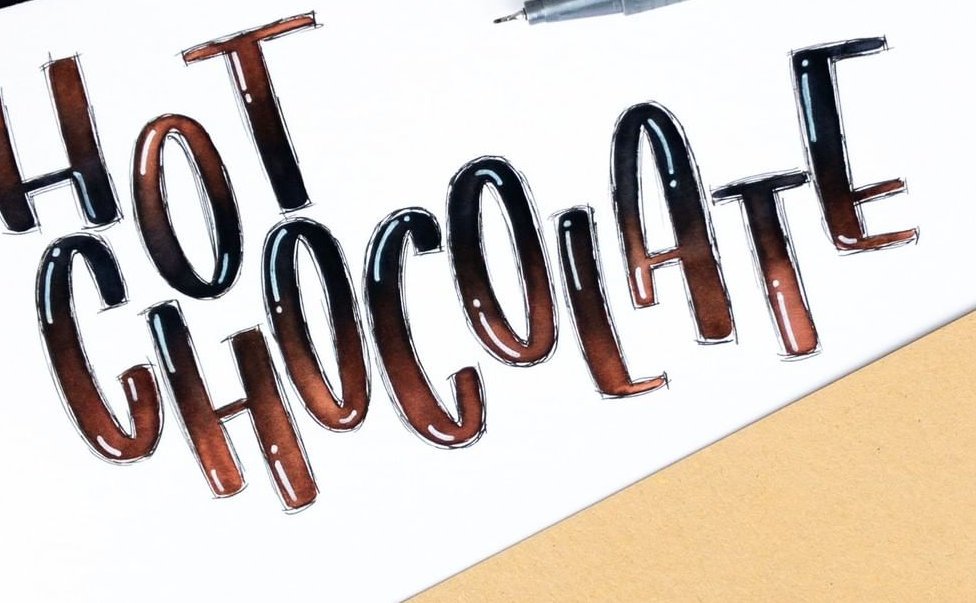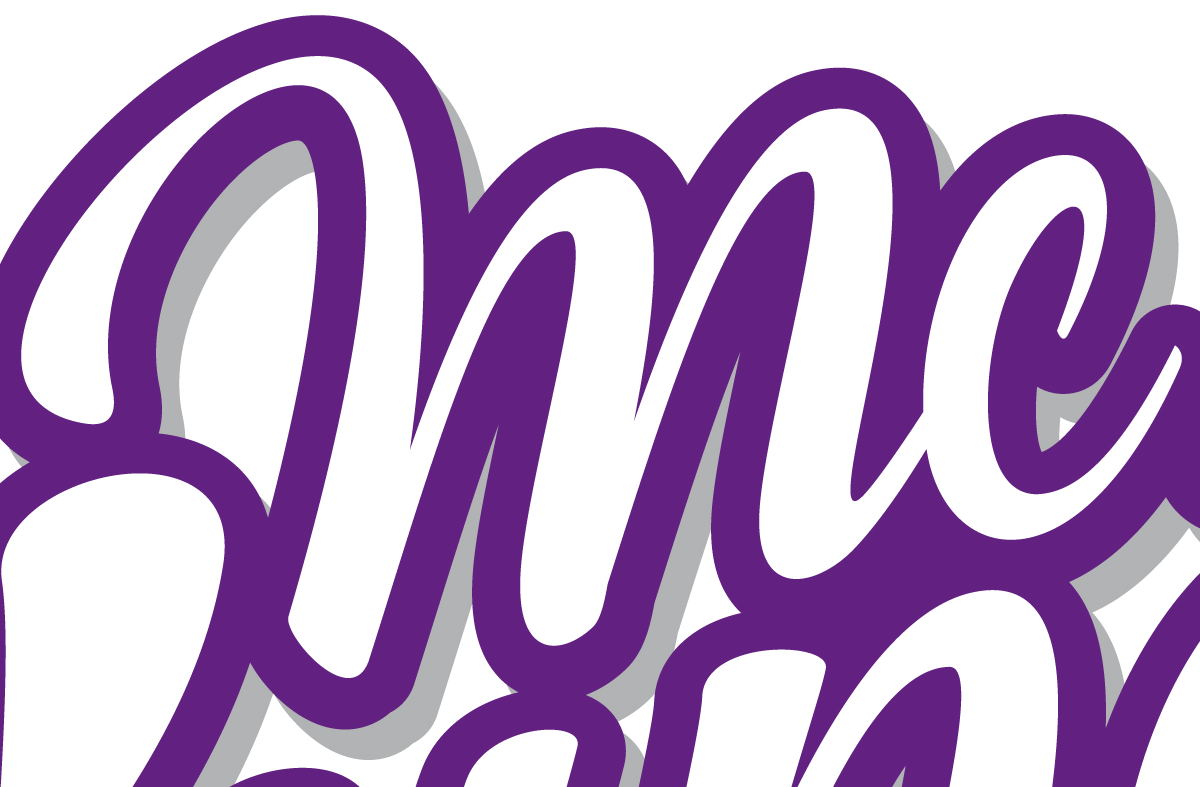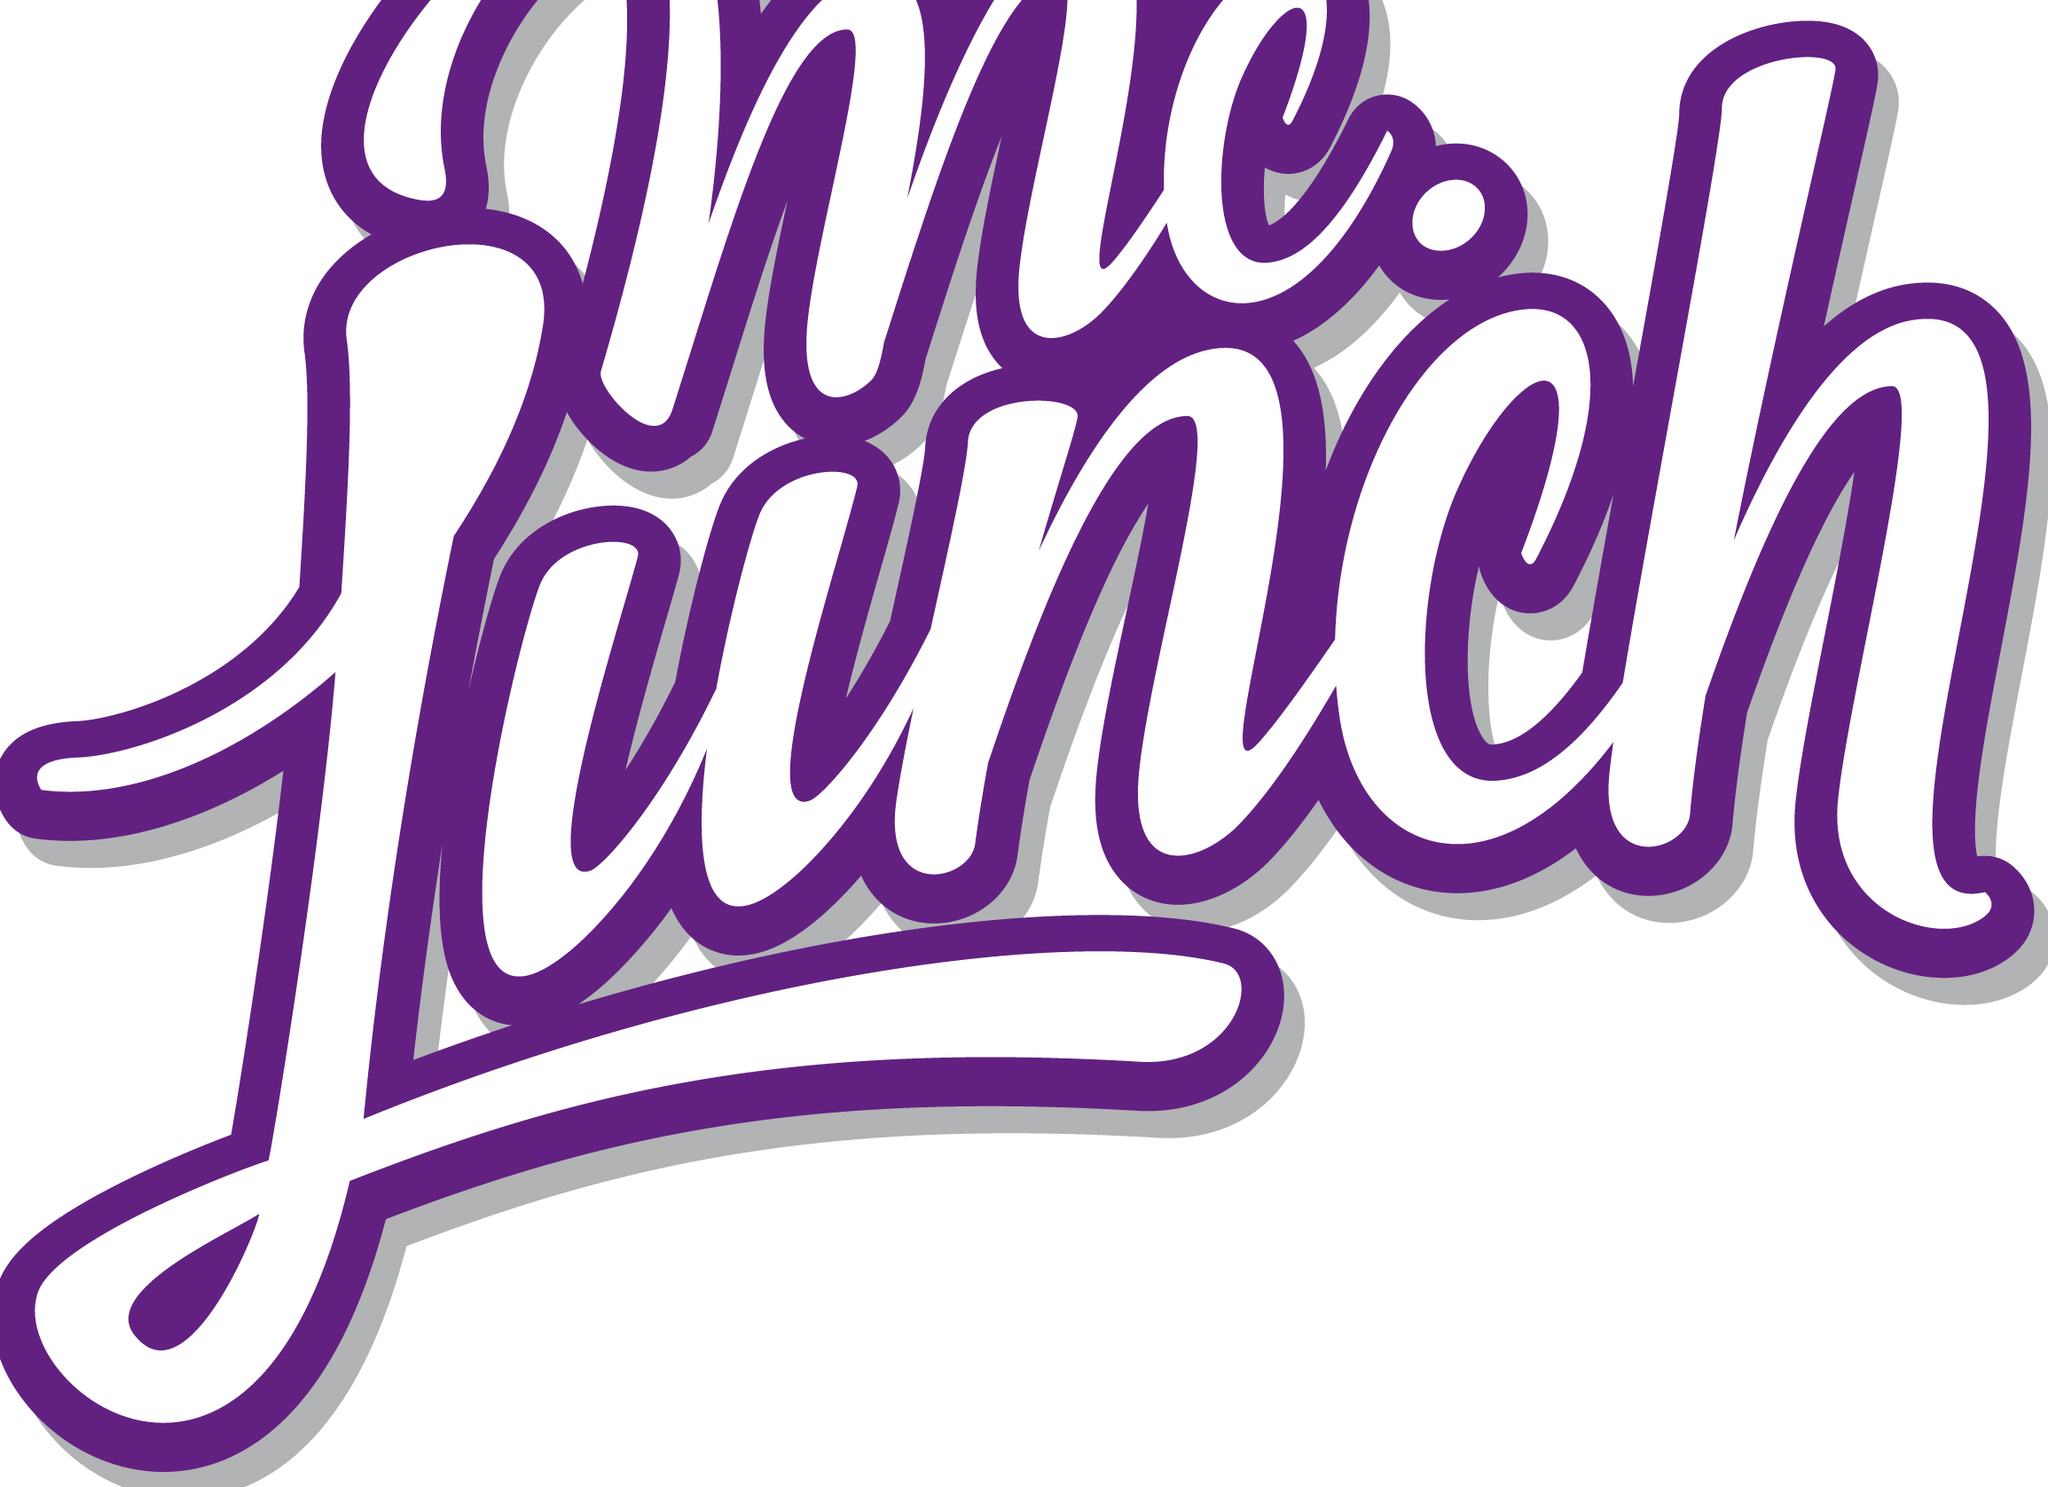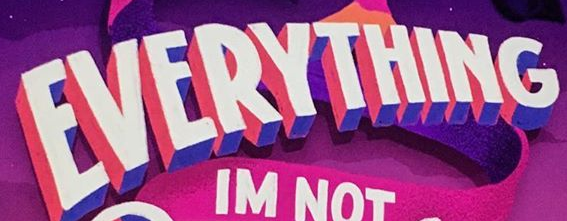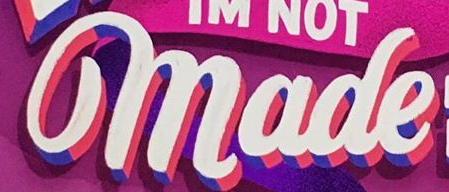What words are shown in these images in order, separated by a semicolon? CHOCOLATE; mc; Lunch; EVERYTHING; made 